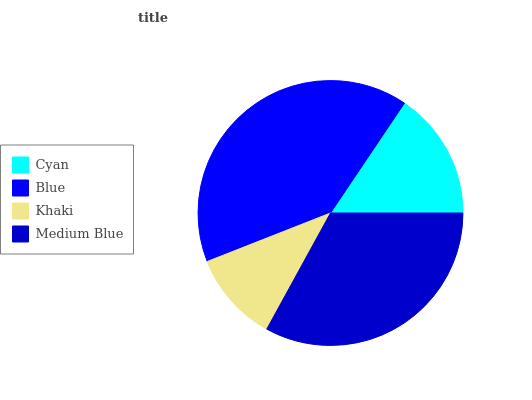Is Khaki the minimum?
Answer yes or no. Yes. Is Blue the maximum?
Answer yes or no. Yes. Is Blue the minimum?
Answer yes or no. No. Is Khaki the maximum?
Answer yes or no. No. Is Blue greater than Khaki?
Answer yes or no. Yes. Is Khaki less than Blue?
Answer yes or no. Yes. Is Khaki greater than Blue?
Answer yes or no. No. Is Blue less than Khaki?
Answer yes or no. No. Is Medium Blue the high median?
Answer yes or no. Yes. Is Cyan the low median?
Answer yes or no. Yes. Is Cyan the high median?
Answer yes or no. No. Is Blue the low median?
Answer yes or no. No. 